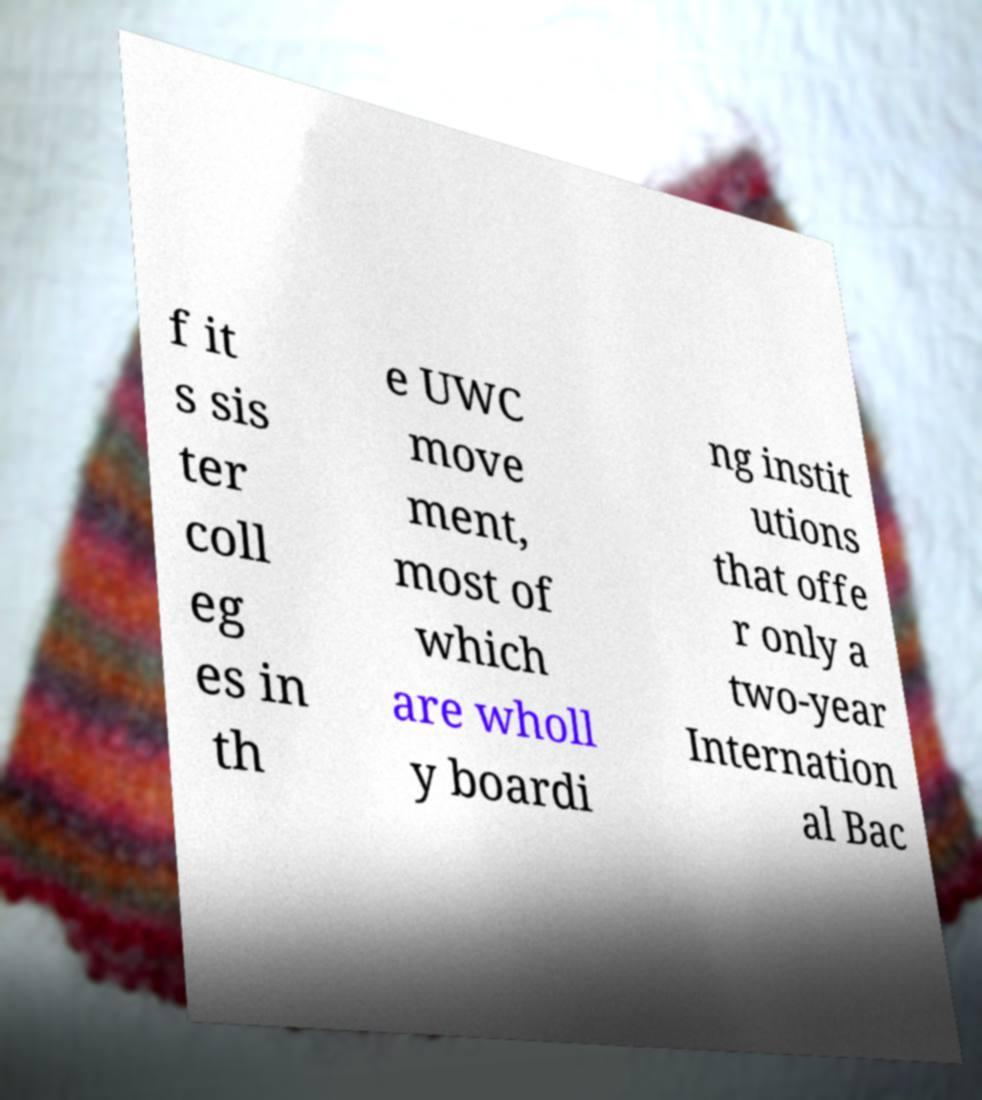Can you accurately transcribe the text from the provided image for me? f it s sis ter coll eg es in th e UWC move ment, most of which are wholl y boardi ng instit utions that offe r only a two-year Internation al Bac 